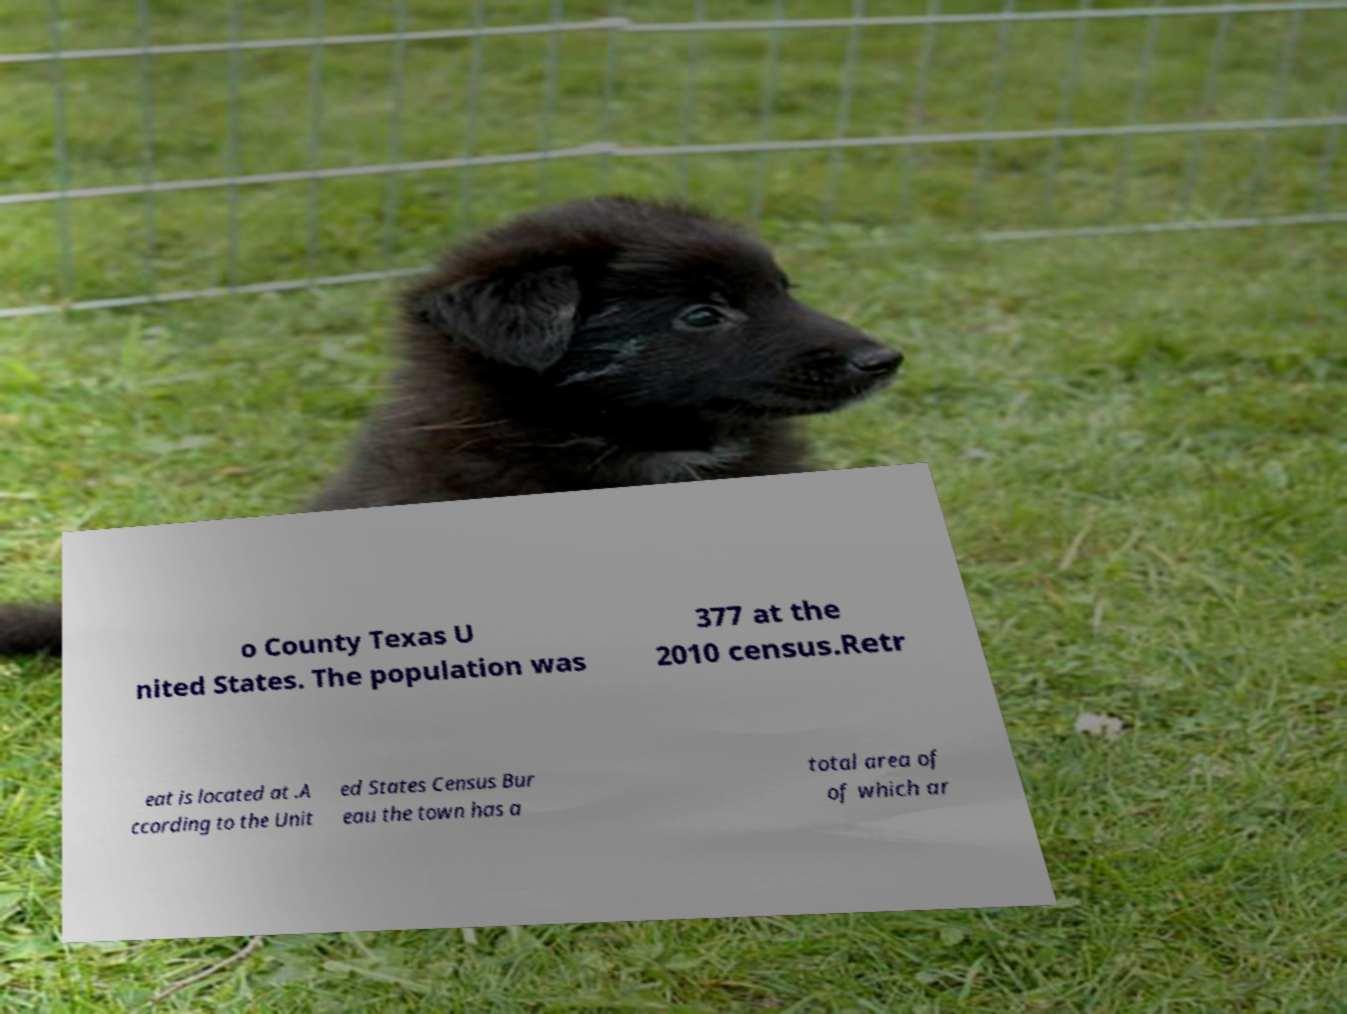For documentation purposes, I need the text within this image transcribed. Could you provide that? o County Texas U nited States. The population was 377 at the 2010 census.Retr eat is located at .A ccording to the Unit ed States Census Bur eau the town has a total area of of which ar 